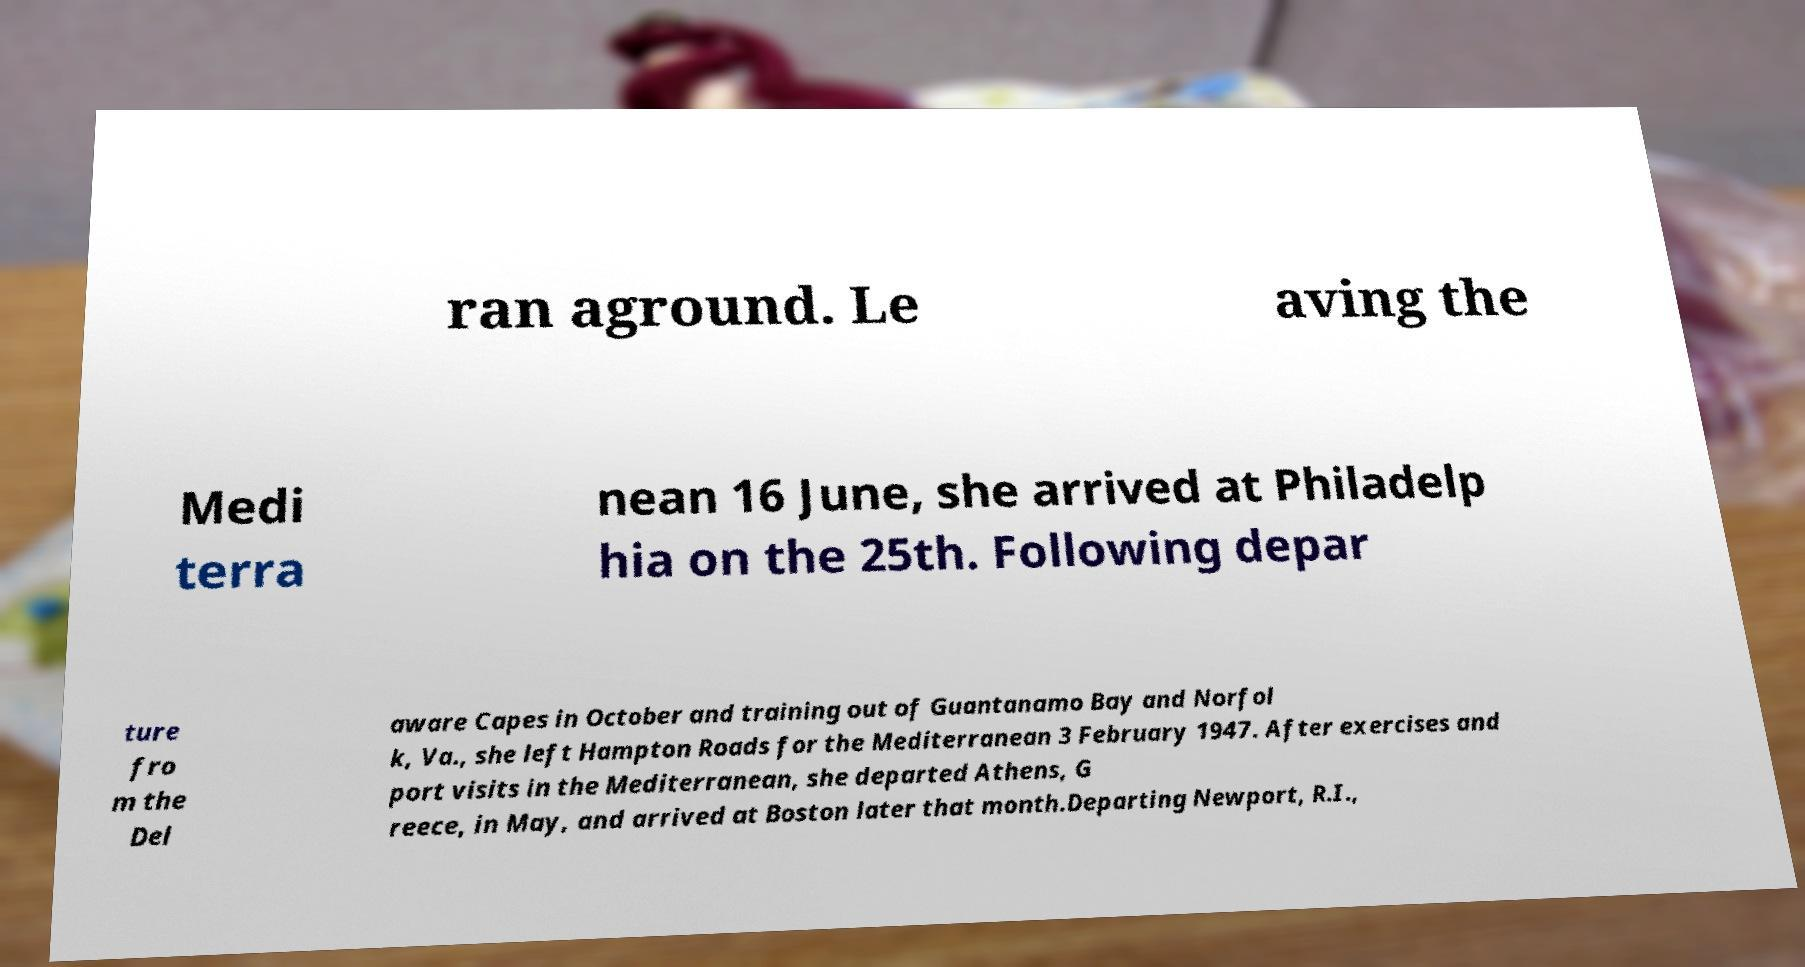For documentation purposes, I need the text within this image transcribed. Could you provide that? ran aground. Le aving the Medi terra nean 16 June, she arrived at Philadelp hia on the 25th. Following depar ture fro m the Del aware Capes in October and training out of Guantanamo Bay and Norfol k, Va., she left Hampton Roads for the Mediterranean 3 February 1947. After exercises and port visits in the Mediterranean, she departed Athens, G reece, in May, and arrived at Boston later that month.Departing Newport, R.I., 